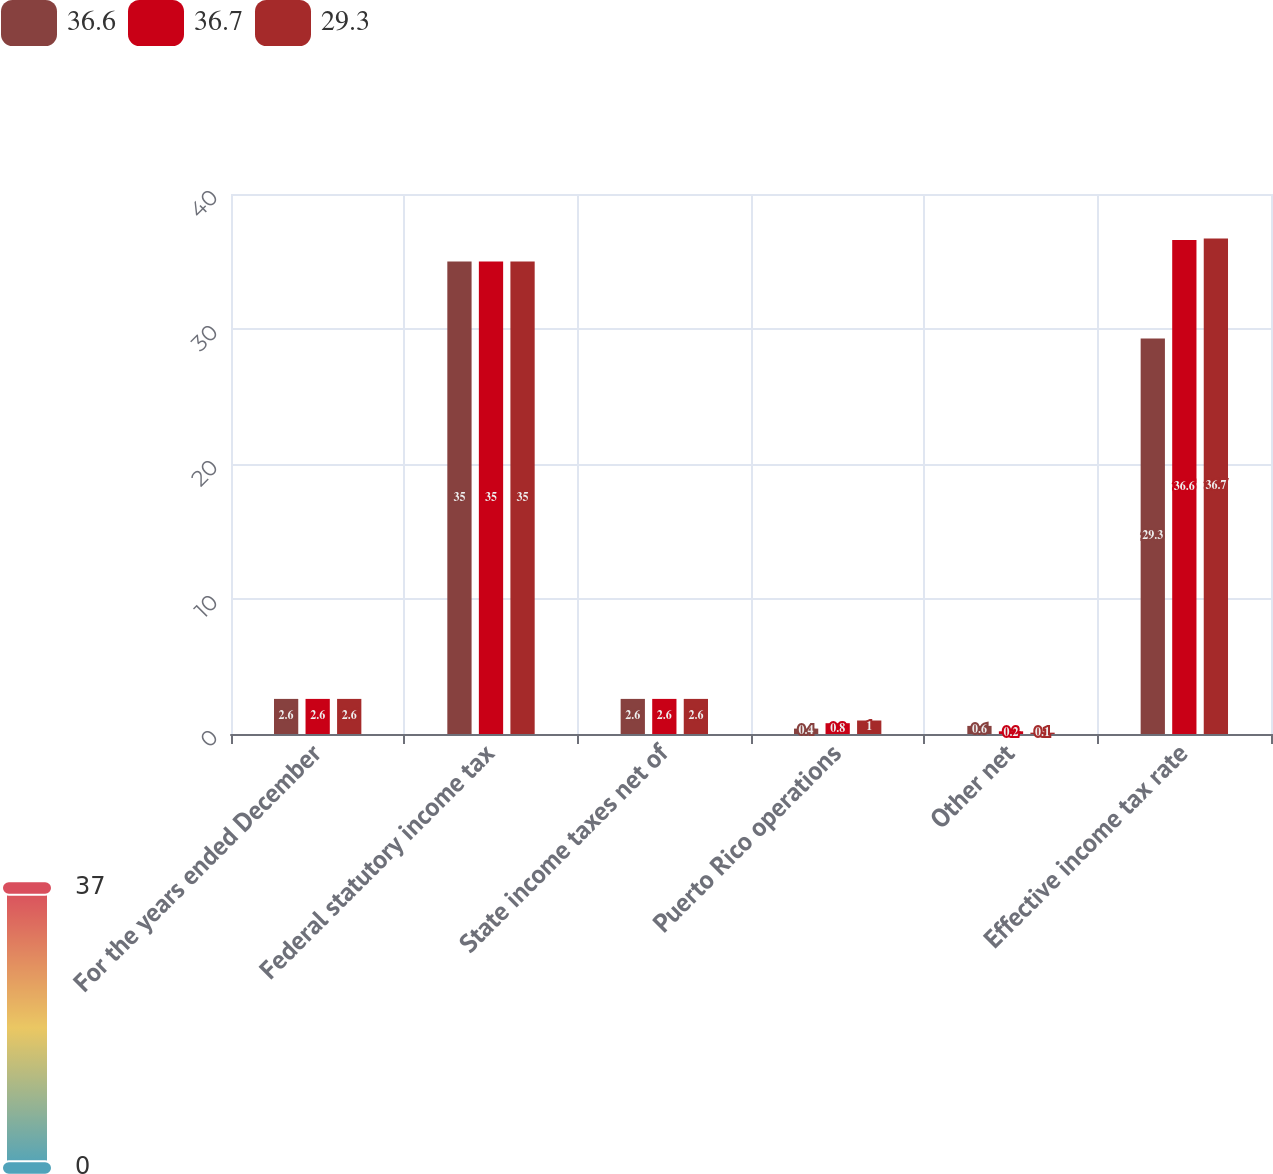<chart> <loc_0><loc_0><loc_500><loc_500><stacked_bar_chart><ecel><fcel>For the years ended December<fcel>Federal statutory income tax<fcel>State income taxes net of<fcel>Puerto Rico operations<fcel>Other net<fcel>Effective income tax rate<nl><fcel>36.6<fcel>2.6<fcel>35<fcel>2.6<fcel>0.4<fcel>0.6<fcel>29.3<nl><fcel>36.7<fcel>2.6<fcel>35<fcel>2.6<fcel>0.8<fcel>0.2<fcel>36.6<nl><fcel>29.3<fcel>2.6<fcel>35<fcel>2.6<fcel>1<fcel>0.1<fcel>36.7<nl></chart> 